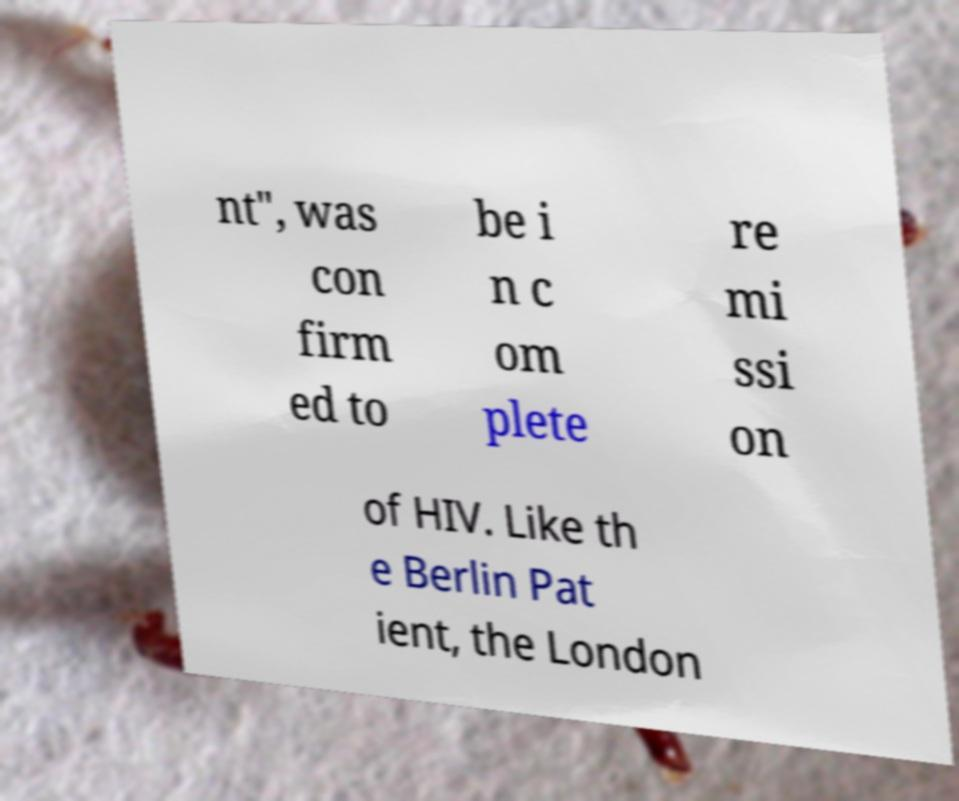I need the written content from this picture converted into text. Can you do that? nt", was con firm ed to be i n c om plete re mi ssi on of HIV. Like th e Berlin Pat ient, the London 